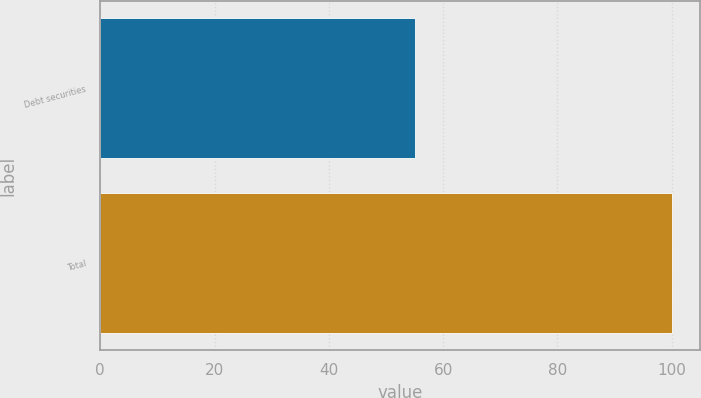Convert chart to OTSL. <chart><loc_0><loc_0><loc_500><loc_500><bar_chart><fcel>Debt securities<fcel>Total<nl><fcel>55<fcel>100<nl></chart> 